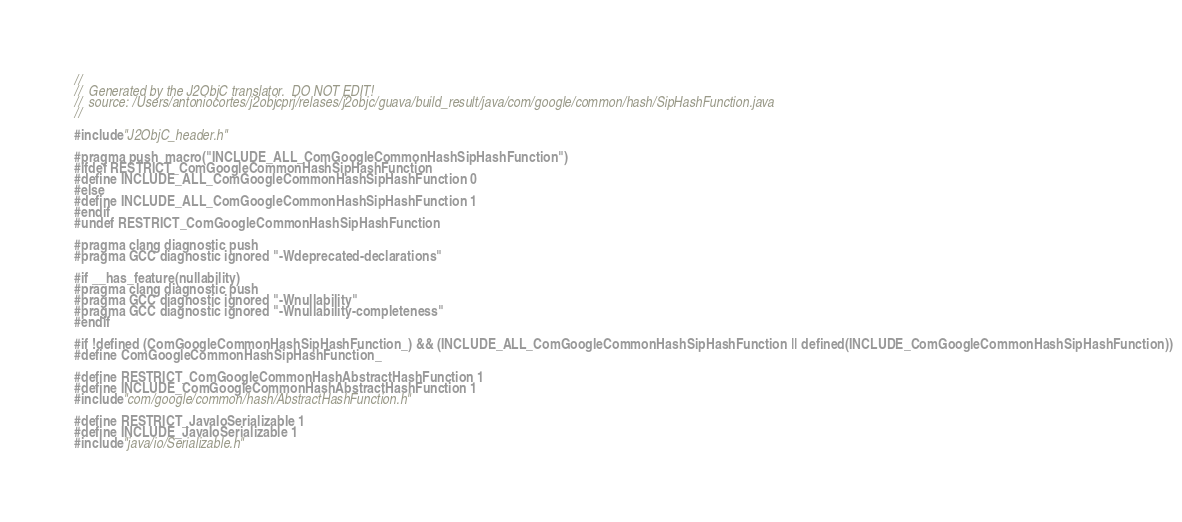<code> <loc_0><loc_0><loc_500><loc_500><_C_>//
//  Generated by the J2ObjC translator.  DO NOT EDIT!
//  source: /Users/antoniocortes/j2objcprj/relases/j2objc/guava/build_result/java/com/google/common/hash/SipHashFunction.java
//

#include "J2ObjC_header.h"

#pragma push_macro("INCLUDE_ALL_ComGoogleCommonHashSipHashFunction")
#ifdef RESTRICT_ComGoogleCommonHashSipHashFunction
#define INCLUDE_ALL_ComGoogleCommonHashSipHashFunction 0
#else
#define INCLUDE_ALL_ComGoogleCommonHashSipHashFunction 1
#endif
#undef RESTRICT_ComGoogleCommonHashSipHashFunction

#pragma clang diagnostic push
#pragma GCC diagnostic ignored "-Wdeprecated-declarations"

#if __has_feature(nullability)
#pragma clang diagnostic push
#pragma GCC diagnostic ignored "-Wnullability"
#pragma GCC diagnostic ignored "-Wnullability-completeness"
#endif

#if !defined (ComGoogleCommonHashSipHashFunction_) && (INCLUDE_ALL_ComGoogleCommonHashSipHashFunction || defined(INCLUDE_ComGoogleCommonHashSipHashFunction))
#define ComGoogleCommonHashSipHashFunction_

#define RESTRICT_ComGoogleCommonHashAbstractHashFunction 1
#define INCLUDE_ComGoogleCommonHashAbstractHashFunction 1
#include "com/google/common/hash/AbstractHashFunction.h"

#define RESTRICT_JavaIoSerializable 1
#define INCLUDE_JavaIoSerializable 1
#include "java/io/Serializable.h"
</code> 